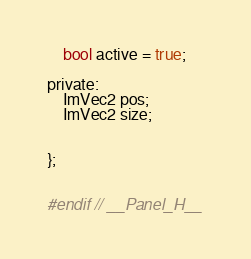<code> <loc_0><loc_0><loc_500><loc_500><_C_>
	bool active = true;

private:
	ImVec2 pos;
	ImVec2 size;


};


#endif // __Panel_H__
</code> 